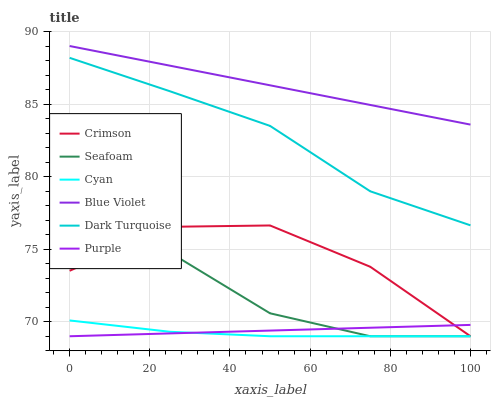Does Cyan have the minimum area under the curve?
Answer yes or no. Yes. Does Blue Violet have the maximum area under the curve?
Answer yes or no. Yes. Does Dark Turquoise have the minimum area under the curve?
Answer yes or no. No. Does Dark Turquoise have the maximum area under the curve?
Answer yes or no. No. Is Purple the smoothest?
Answer yes or no. Yes. Is Seafoam the roughest?
Answer yes or no. Yes. Is Dark Turquoise the smoothest?
Answer yes or no. No. Is Dark Turquoise the roughest?
Answer yes or no. No. Does Purple have the lowest value?
Answer yes or no. Yes. Does Dark Turquoise have the lowest value?
Answer yes or no. No. Does Blue Violet have the highest value?
Answer yes or no. Yes. Does Dark Turquoise have the highest value?
Answer yes or no. No. Is Seafoam less than Dark Turquoise?
Answer yes or no. Yes. Is Dark Turquoise greater than Seafoam?
Answer yes or no. Yes. Does Purple intersect Crimson?
Answer yes or no. Yes. Is Purple less than Crimson?
Answer yes or no. No. Is Purple greater than Crimson?
Answer yes or no. No. Does Seafoam intersect Dark Turquoise?
Answer yes or no. No. 